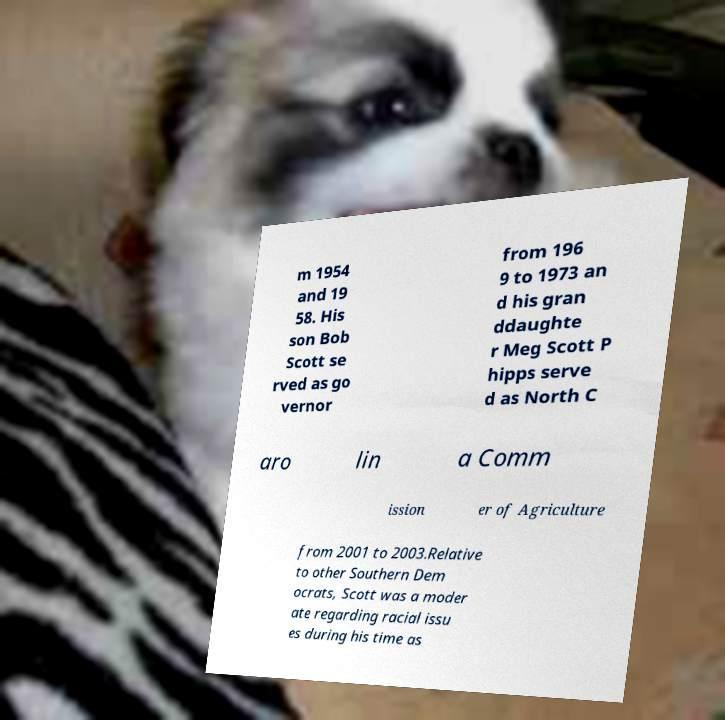Please read and relay the text visible in this image. What does it say? m 1954 and 19 58. His son Bob Scott se rved as go vernor from 196 9 to 1973 an d his gran ddaughte r Meg Scott P hipps serve d as North C aro lin a Comm ission er of Agriculture from 2001 to 2003.Relative to other Southern Dem ocrats, Scott was a moder ate regarding racial issu es during his time as 